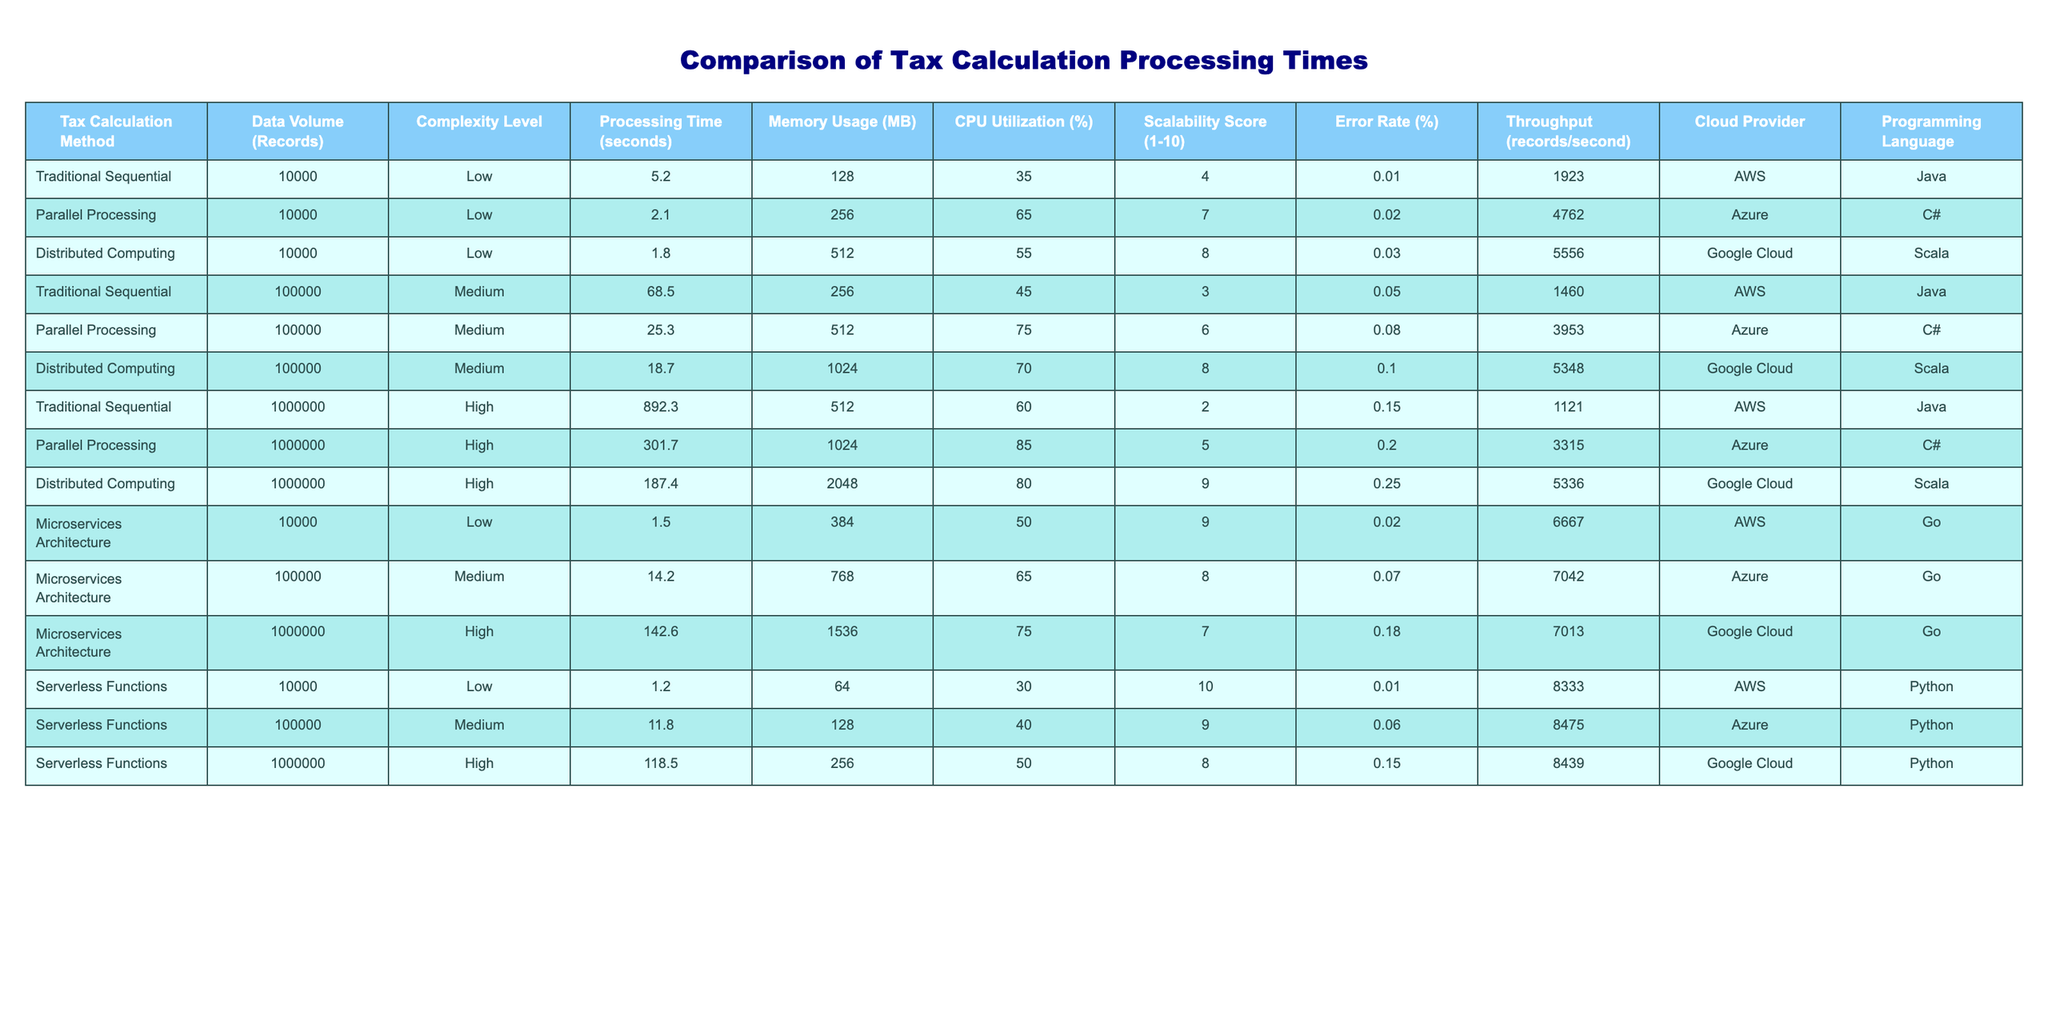What is the processing time for the Parallel Processing method with 1,000,000 records? The table states that for the Parallel Processing method with a data volume of 1,000,000 records, the processing time is 301.7 seconds.
Answer: 301.7 seconds What is the maximum memory usage recorded in the table? The highest memory usage recorded in the table is 2048 MB, associated with the Distributed Computing method for 1,000,000 records.
Answer: 2048 MB How does the scalability score of Microservices Architecture compare to that of Traditional Sequential for 100,000 records? Microservices Architecture has a scalability score of 8, while Traditional Sequential has a score of 3 for the same data volume of 100,000 records.
Answer: Microservices Architecture is higher What is the average processing time for methods at the high complexity level? There are three high complexity methods: Traditional Sequential (892.3 seconds), Parallel Processing (301.7 seconds), and Distributed Computing (187.4 seconds). Their sum is 1381.4 seconds and the average is 1381.4/3 = 460.47 seconds.
Answer: 460.47 seconds Is the error rate for Serverless Functions higher than that for Parallel Processing at 100,000 records? The error rate for Serverless Functions at 100,000 records is 0.06%, and the error rate for Parallel Processing at 100,000 records is 0.08%. Since 0.06% is less, the statement is false.
Answer: No Which cloud provider had the highest throughput for the 1,000,000 records at high complexity? The table shows that the highest throughput for the 1,000,000 records at high complexity is 5336 records/second with Google Cloud using Distributed Computing.
Answer: Google Cloud What is the difference in processing time between Distributed Computing and Microservices Architecture for 100,000 records? Distributed Computing has a processing time of 18.7 seconds and Microservices Architecture has a processing time of 14.2 seconds. The difference is 18.7 - 14.2 = 4.5 seconds.
Answer: 4.5 seconds Which programming language has the lowest memory usage in the table? The programming language with the lowest recorded memory usage is Python, specifically used in Serverless Functions with 64 MB for 10,000 records.
Answer: Python What is the average CPU utilization across all methods for 100,000 records? The CPU utilization values for methods at 100,000 records are 45% (Traditional Sequential), 75% (Parallel Processing), and 70% (Distributed Computing), summing to 190%. The average is 190%/3 = 63.33%.
Answer: 63.33% Does any method achieve a perfect scalability score? The table indicates that no method achieves a perfect scalability score of 10; the highest score listed is 10 for Serverless Functions at 10,000 records.
Answer: Yes, Serverless Functions at 10,000 records does Which method offers the best throughput for 10,000 records? The best throughput for 10,000 records is 8333 records/second, offered by Serverless Functions.
Answer: Serverless Functions 